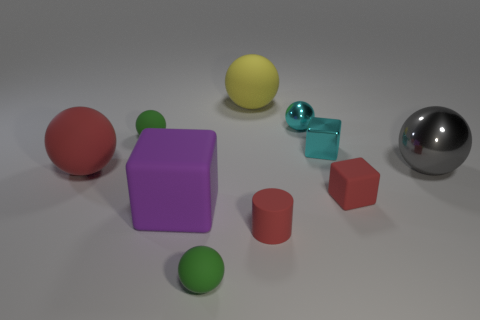What is the size of the gray ball that is the same material as the cyan block?
Provide a short and direct response. Large. What number of red objects are tiny cylinders or metallic balls?
Your response must be concise. 1. Are there more spheres than objects?
Provide a short and direct response. No. The metallic sphere that is the same size as the red cylinder is what color?
Provide a succinct answer. Cyan. What number of balls are either tiny metallic objects or large gray shiny objects?
Offer a very short reply. 2. Do the gray shiny object and the tiny cyan shiny thing that is behind the tiny shiny cube have the same shape?
Offer a terse response. Yes. What number of cyan objects have the same size as the red cylinder?
Keep it short and to the point. 2. Is the shape of the green object in front of the big red ball the same as the big matte object behind the large shiny sphere?
Offer a very short reply. Yes. There is a thing that is the same color as the small metal sphere; what is its shape?
Offer a very short reply. Cube. What color is the large rubber ball to the right of the green rubber thing that is right of the purple matte object?
Make the answer very short. Yellow. 